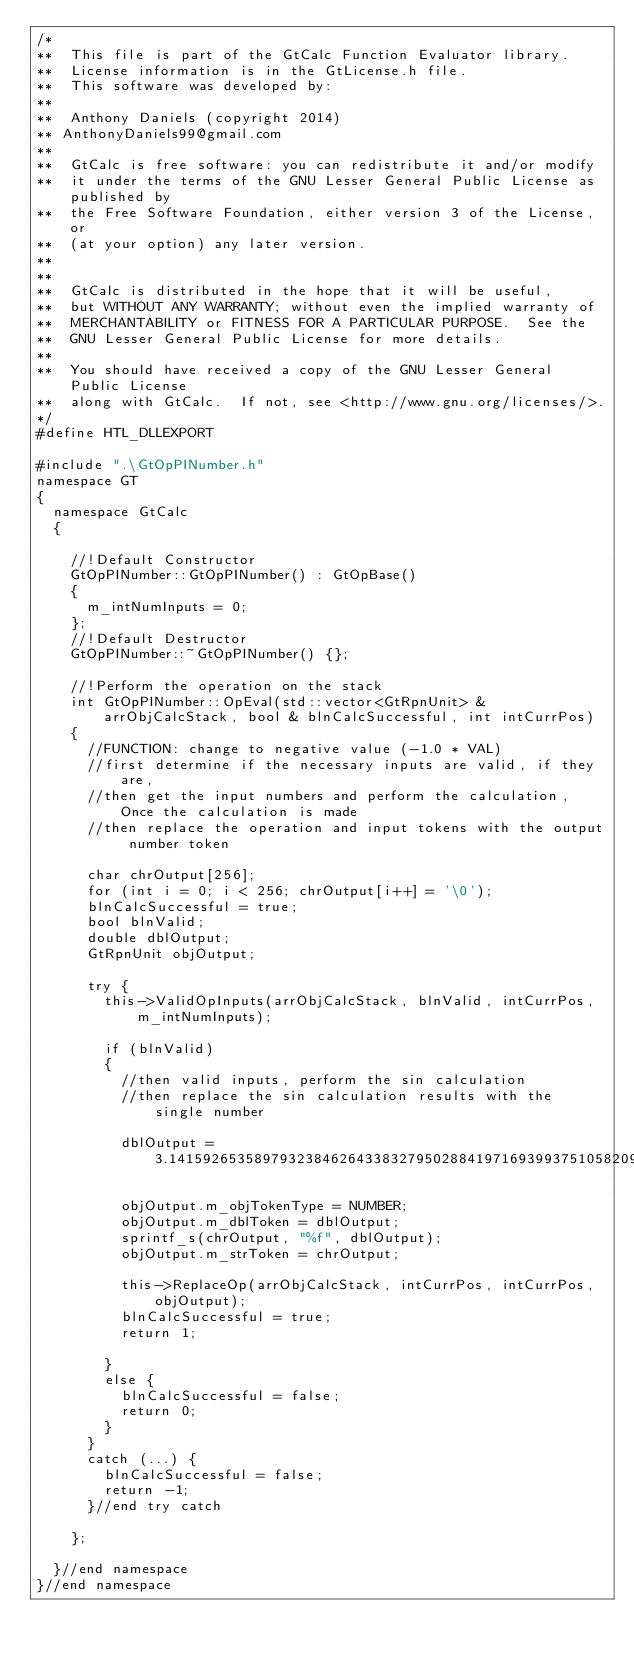Convert code to text. <code><loc_0><loc_0><loc_500><loc_500><_C++_>/*
**	This file is part of the GtCalc Function Evaluator library.
**  License information is in the GtLicense.h file.
**	This software was developed by:
**	
**  Anthony Daniels (copyright 2014)
** AnthonyDaniels99@gmail.com
**
**  GtCalc is free software: you can redistribute it and/or modify
**  it under the terms of the GNU Lesser General Public License as published by
**  the Free Software Foundation, either version 3 of the License, or
**  (at your option) any later version.
**
**
**  GtCalc is distributed in the hope that it will be useful,
**  but WITHOUT ANY WARRANTY; without even the implied warranty of
**  MERCHANTABILITY or FITNESS FOR A PARTICULAR PURPOSE.  See the
**  GNU Lesser General Public License for more details.
**
**  You should have received a copy of the GNU Lesser General Public License
**  along with GtCalc.  If not, see <http://www.gnu.org/licenses/>.
*/
#define HTL_DLLEXPORT

#include ".\GtOpPINumber.h"
namespace GT
{
	namespace GtCalc
	{

		//!Default Constructor
		GtOpPINumber::GtOpPINumber() : GtOpBase()
		{
			m_intNumInputs = 0;
		};
		//!Default Destructor
		GtOpPINumber::~GtOpPINumber() {};

		//!Perform the operation on the stack
		int GtOpPINumber::OpEval(std::vector<GtRpnUnit> & arrObjCalcStack, bool & blnCalcSuccessful, int intCurrPos)
		{
			//FUNCTION: change to negative value (-1.0 * VAL)
			//first determine if the necessary inputs are valid, if they are,
			//then get the input numbers and perform the calculation, Once the calculation is made
			//then replace the operation and input tokens with the output number token

			char chrOutput[256];
			for (int i = 0; i < 256; chrOutput[i++] = '\0');
			blnCalcSuccessful = true;
			bool blnValid;
			double dblOutput;
			GtRpnUnit objOutput;

			try {
				this->ValidOpInputs(arrObjCalcStack, blnValid, intCurrPos, m_intNumInputs);

				if (blnValid)
				{
					//then valid inputs, perform the sin calculation
					//then replace the sin calculation results with the single number
					
					dblOutput = 3.141592653589793238462643383279502884197169399375105820974944592307816406286;

					objOutput.m_objTokenType = NUMBER;
					objOutput.m_dblToken = dblOutput;
					sprintf_s(chrOutput, "%f", dblOutput);
					objOutput.m_strToken = chrOutput;

					this->ReplaceOp(arrObjCalcStack, intCurrPos, intCurrPos, objOutput);
					blnCalcSuccessful = true;
					return 1;

				}
				else {
					blnCalcSuccessful = false;
					return 0;
				}
			}
			catch (...) {
				blnCalcSuccessful = false;
				return -1;
			}//end try catch

		};

	}//end namespace
}//end namespace</code> 